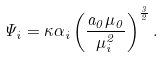<formula> <loc_0><loc_0><loc_500><loc_500>\Psi _ { i } = \kappa \alpha _ { i } \left ( \frac { a _ { 0 } \mu _ { 0 } } { \mu _ { i } ^ { 2 } } \right ) ^ { \frac { 3 } { 2 } } .</formula> 